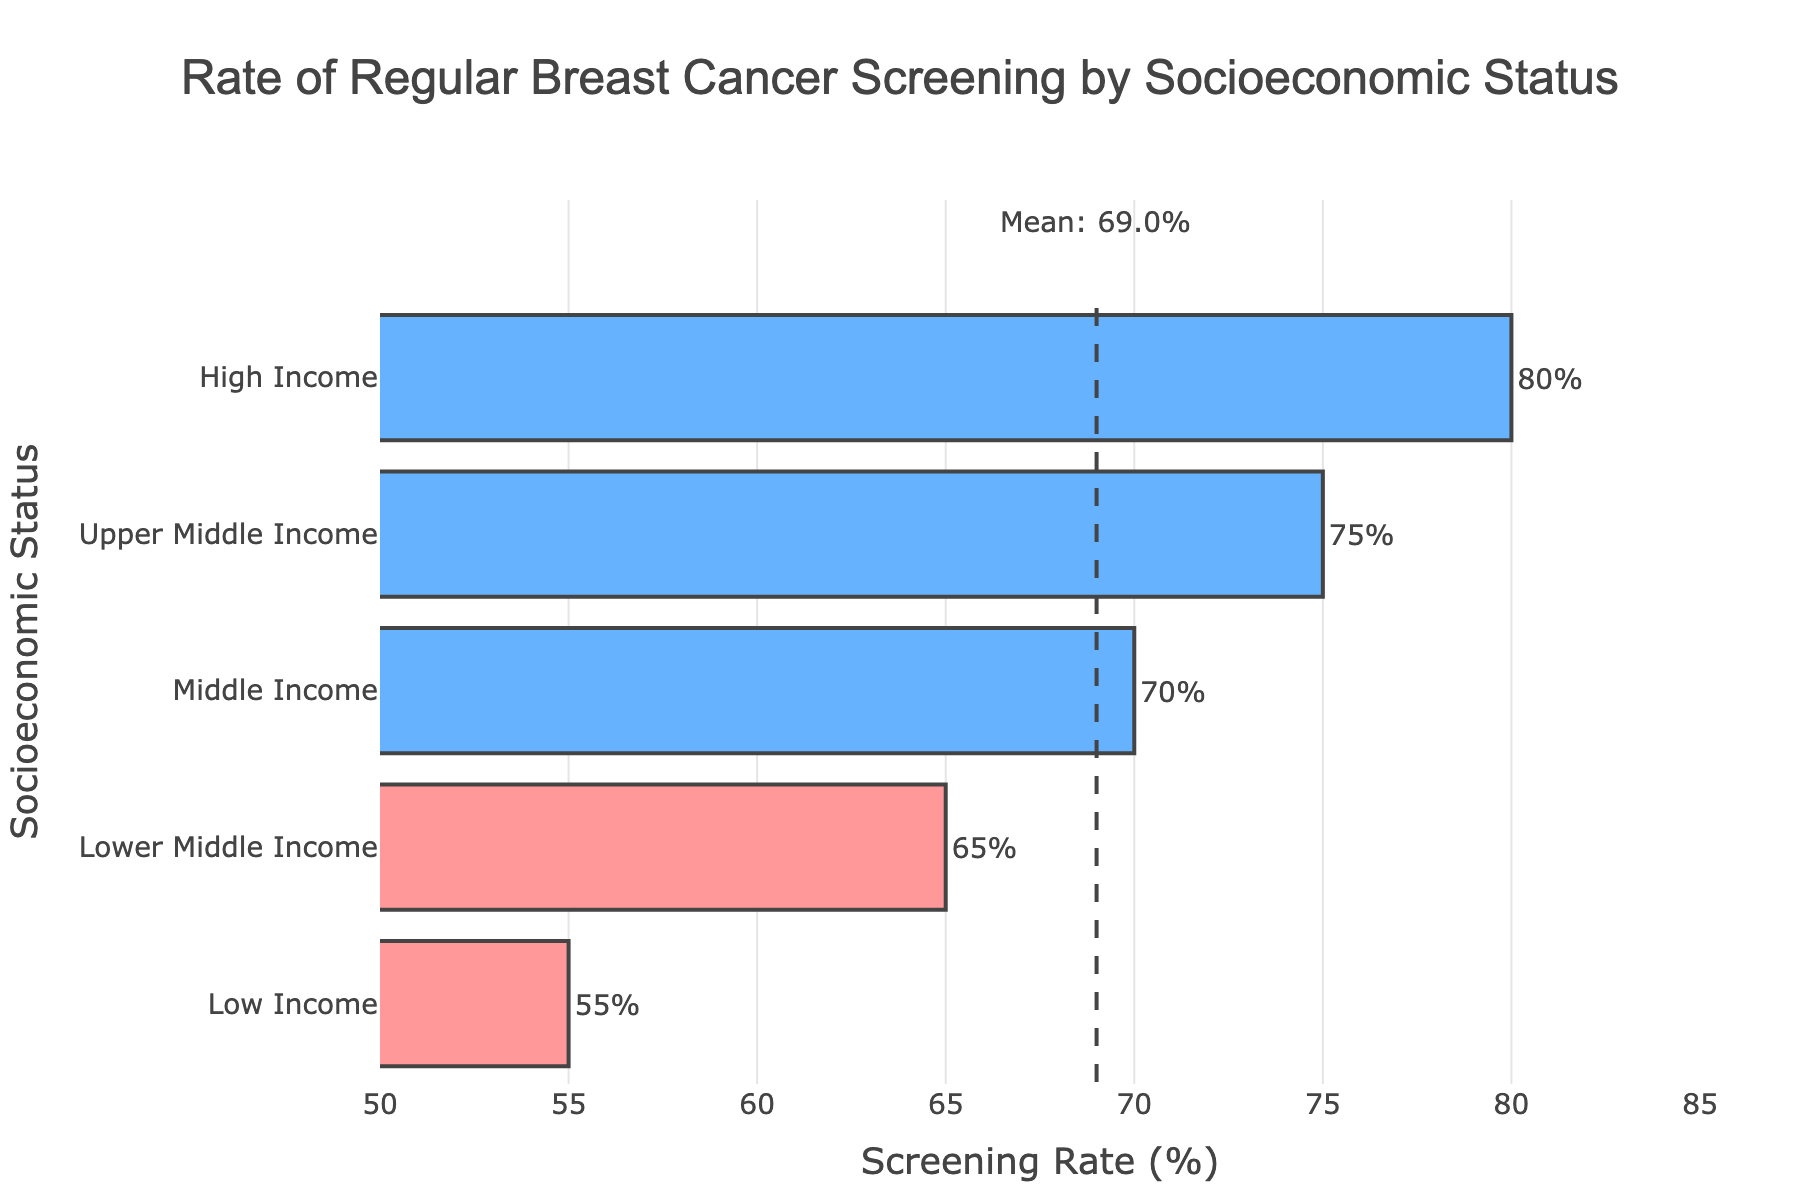Which socioeconomic status has the highest rate of regular breast cancer screening? Look at the bar with the greatest length. It represents High Income, which has a screening rate of 80%.
Answer: High Income Which socioeconomic status has the lowest rate of regular breast cancer screening? Look at the shortest bar. It represents Low Income, which has a rate of 55%.
Answer: Low Income What's the difference in the rates of regular breast cancer screening between High Income and Low Income groups? Subtract the rate of Low Income (55%) from the rate of High Income (80%). So, 80 - 55 = 25.
Answer: 25% How does the rate of Upper Middle Income compare to the average rate? Check the position of the Upper Middle Income bar relative to the mean line. Upper Middle Income has a 75% rate, which is higher than the mean (69%).
Answer: Higher What is the mean rate of regular breast cancer screening across all groups? There is a vertical dashed line indicating the mean rate at 69%.
Answer: 69% Which groups have a screening rate below the mean rate? Observe which bars are colored red, representing rates lower than the mean. Low Income (55%) and Lower Middle Income (65%) have rates below the mean.
Answer: Low Income, Lower Middle Income Are there more socioeconomic groups with screening rates above or below the mean? Count the bars colored blue (above) and red (below). There are 3 blue bars (above) and 2 red bars (below).
Answer: Above What is the combined rate of screening for Middle Income and Upper Middle Income groups? Add the rates: Middle Income (70%) + Upper Middle Income (75%) = 145%.
Answer: 145% How many groups have a screening rate of 70% or more? Identify and count the bars with lengths extending to 70% or more. These are Middle Income (70%), Upper Middle Income (75%), and High Income (80%).
Answer: 3 What is the difference between the Upper Middle Income and Lower Middle Income screening rates? Subtract the rate of Lower Middle Income (65%) from Upper Middle Income (75%). So, 75 - 65 = 10.
Answer: 10% 